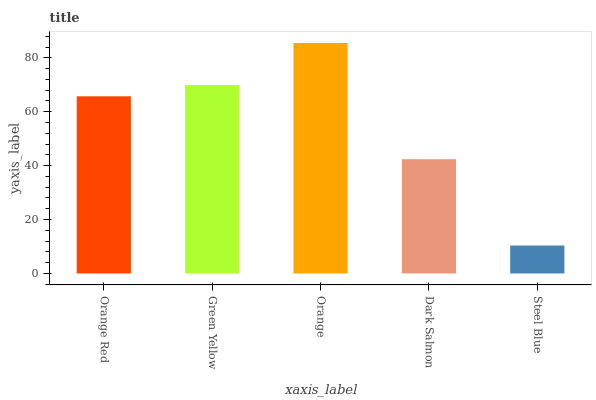Is Steel Blue the minimum?
Answer yes or no. Yes. Is Orange the maximum?
Answer yes or no. Yes. Is Green Yellow the minimum?
Answer yes or no. No. Is Green Yellow the maximum?
Answer yes or no. No. Is Green Yellow greater than Orange Red?
Answer yes or no. Yes. Is Orange Red less than Green Yellow?
Answer yes or no. Yes. Is Orange Red greater than Green Yellow?
Answer yes or no. No. Is Green Yellow less than Orange Red?
Answer yes or no. No. Is Orange Red the high median?
Answer yes or no. Yes. Is Orange Red the low median?
Answer yes or no. Yes. Is Dark Salmon the high median?
Answer yes or no. No. Is Dark Salmon the low median?
Answer yes or no. No. 